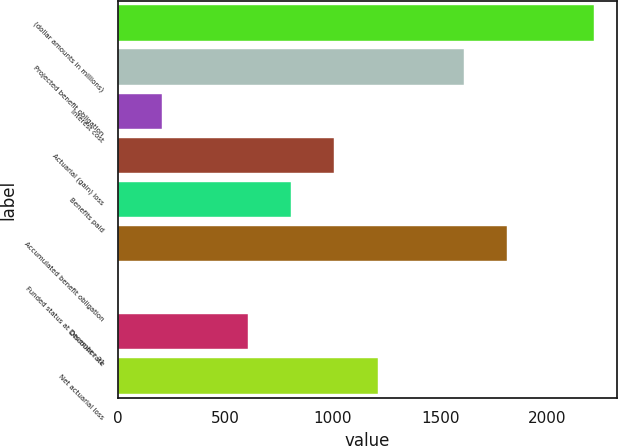Convert chart to OTSL. <chart><loc_0><loc_0><loc_500><loc_500><bar_chart><fcel>(dollar amounts in millions)<fcel>Projected benefit obligation<fcel>Interest cost<fcel>Actuarial (gain) loss<fcel>Benefits paid<fcel>Accumulated benefit obligation<fcel>Funded status at December 31<fcel>Discount rate<fcel>Net actuarial loss<nl><fcel>2214.1<fcel>1610.8<fcel>203.1<fcel>1007.5<fcel>806.4<fcel>1811.9<fcel>2<fcel>605.3<fcel>1208.6<nl></chart> 